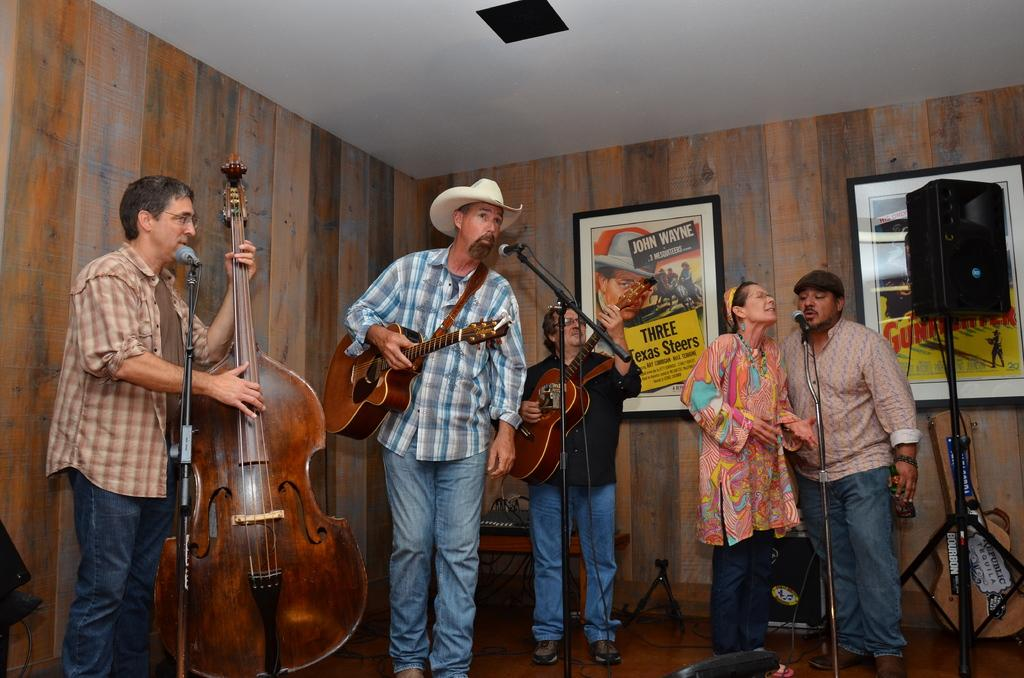What instrument is the man playing in the image? The man is playing a violin in the image. How many people are playing guitar in the image? There are two men playing guitar in the image. What are the two people doing in the image? The two people are singing in the image. What is being used by the singers to amplify their voices? A microphone is being used by the singers. What type of knee support is being used by the guitarist on the left? There is no mention of knee support in the image. How does the power of the microphone affect the comfort of the singers? There is no mention of power or comfort in the image. 